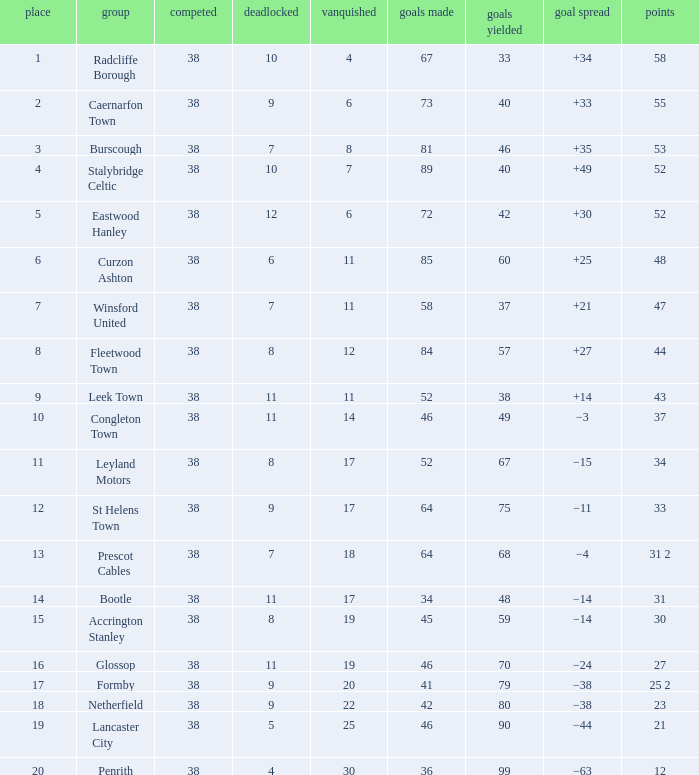WHAT GOALS AGAINST HAD A GOAL FOR OF 46, AND PLAYED LESS THAN 38? None. 